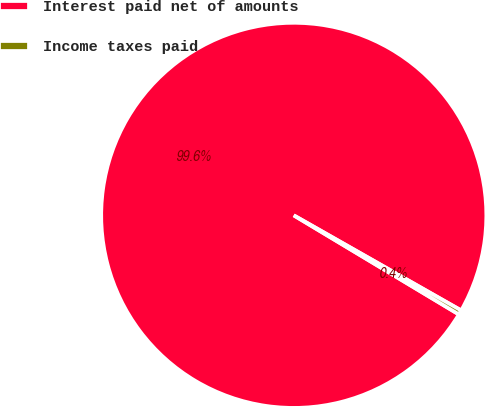<chart> <loc_0><loc_0><loc_500><loc_500><pie_chart><fcel>Interest paid net of amounts<fcel>Income taxes paid<nl><fcel>99.62%<fcel>0.38%<nl></chart> 